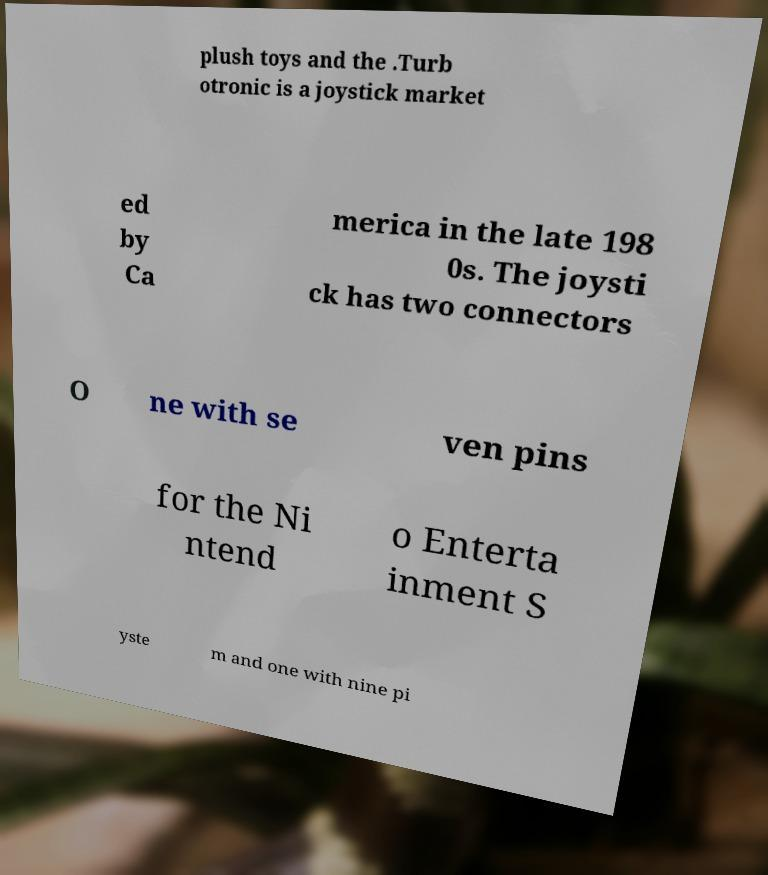For documentation purposes, I need the text within this image transcribed. Could you provide that? plush toys and the .Turb otronic is a joystick market ed by Ca merica in the late 198 0s. The joysti ck has two connectors O ne with se ven pins for the Ni ntend o Enterta inment S yste m and one with nine pi 